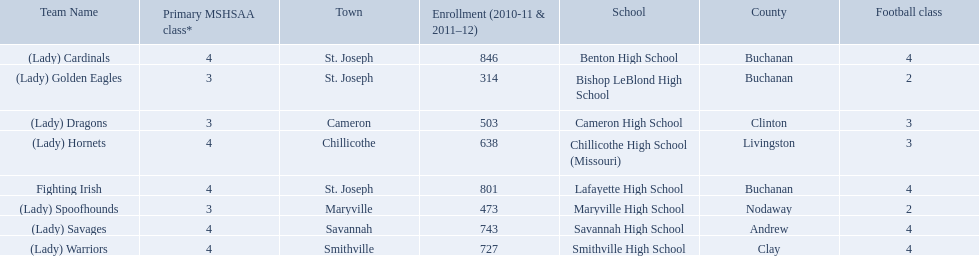What school in midland empire conference has 846 students enrolled? Benton High School. What school has 314 students enrolled? Bishop LeBlond High School. What school had 638 students enrolled? Chillicothe High School (Missouri). 